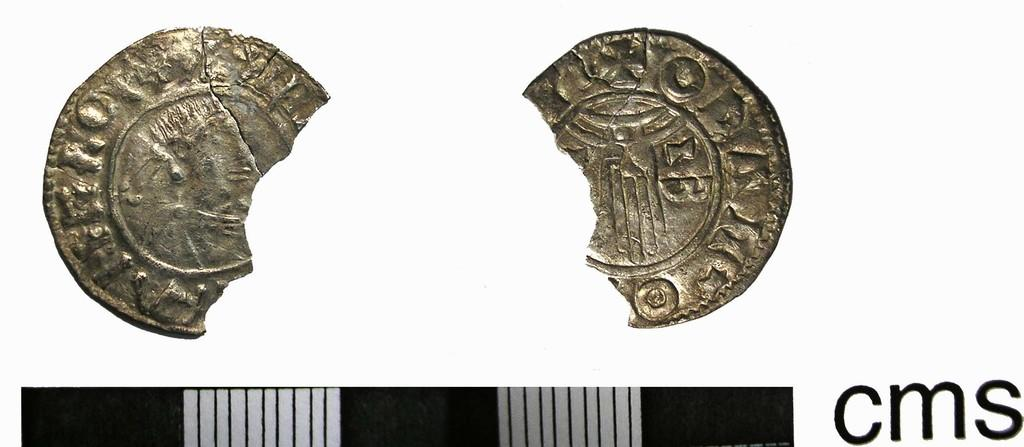What is depicted in the image involving coins? There is an art of two broken coins in the image. What else is featured in the image besides the broken coins? There is text in the image. What is the tendency of the goose in the image? There is no goose present in the image, so it is not possible to determine its tendency. 